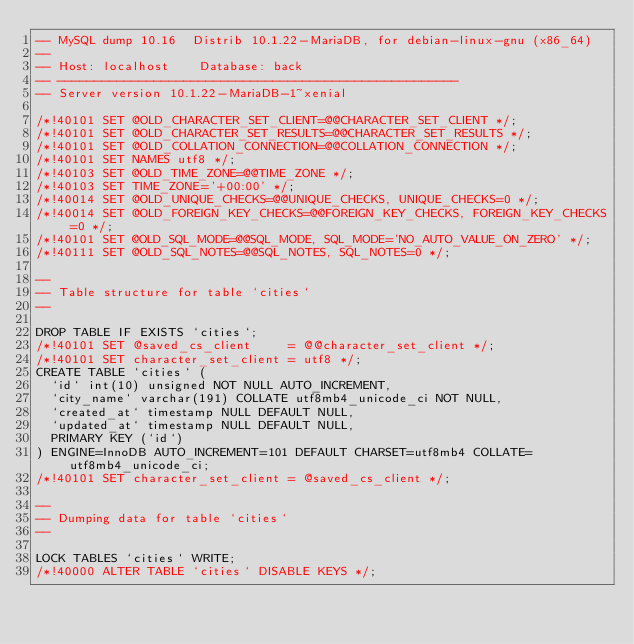<code> <loc_0><loc_0><loc_500><loc_500><_SQL_>-- MySQL dump 10.16  Distrib 10.1.22-MariaDB, for debian-linux-gnu (x86_64)
--
-- Host: localhost    Database: back
-- ------------------------------------------------------
-- Server version	10.1.22-MariaDB-1~xenial

/*!40101 SET @OLD_CHARACTER_SET_CLIENT=@@CHARACTER_SET_CLIENT */;
/*!40101 SET @OLD_CHARACTER_SET_RESULTS=@@CHARACTER_SET_RESULTS */;
/*!40101 SET @OLD_COLLATION_CONNECTION=@@COLLATION_CONNECTION */;
/*!40101 SET NAMES utf8 */;
/*!40103 SET @OLD_TIME_ZONE=@@TIME_ZONE */;
/*!40103 SET TIME_ZONE='+00:00' */;
/*!40014 SET @OLD_UNIQUE_CHECKS=@@UNIQUE_CHECKS, UNIQUE_CHECKS=0 */;
/*!40014 SET @OLD_FOREIGN_KEY_CHECKS=@@FOREIGN_KEY_CHECKS, FOREIGN_KEY_CHECKS=0 */;
/*!40101 SET @OLD_SQL_MODE=@@SQL_MODE, SQL_MODE='NO_AUTO_VALUE_ON_ZERO' */;
/*!40111 SET @OLD_SQL_NOTES=@@SQL_NOTES, SQL_NOTES=0 */;

--
-- Table structure for table `cities`
--

DROP TABLE IF EXISTS `cities`;
/*!40101 SET @saved_cs_client     = @@character_set_client */;
/*!40101 SET character_set_client = utf8 */;
CREATE TABLE `cities` (
  `id` int(10) unsigned NOT NULL AUTO_INCREMENT,
  `city_name` varchar(191) COLLATE utf8mb4_unicode_ci NOT NULL,
  `created_at` timestamp NULL DEFAULT NULL,
  `updated_at` timestamp NULL DEFAULT NULL,
  PRIMARY KEY (`id`)
) ENGINE=InnoDB AUTO_INCREMENT=101 DEFAULT CHARSET=utf8mb4 COLLATE=utf8mb4_unicode_ci;
/*!40101 SET character_set_client = @saved_cs_client */;

--
-- Dumping data for table `cities`
--

LOCK TABLES `cities` WRITE;
/*!40000 ALTER TABLE `cities` DISABLE KEYS */;</code> 